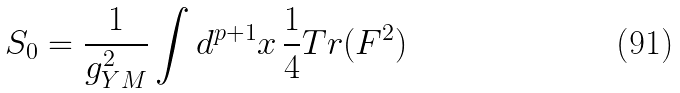<formula> <loc_0><loc_0><loc_500><loc_500>S _ { 0 } = { \frac { 1 } { g _ { Y M } ^ { 2 } } } \int d ^ { p + 1 } x \, { \frac { 1 } { 4 } } T r ( F ^ { 2 } )</formula> 